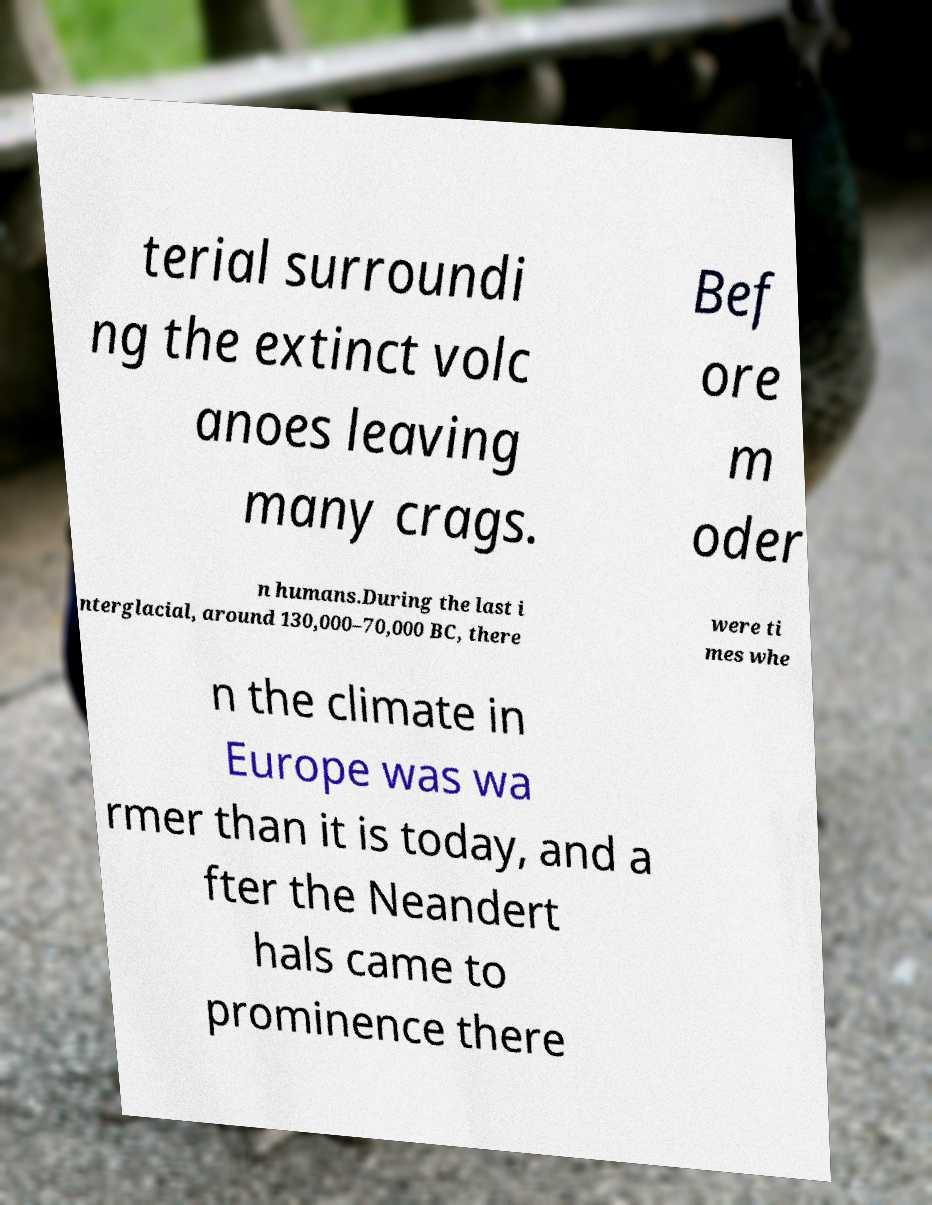For documentation purposes, I need the text within this image transcribed. Could you provide that? terial surroundi ng the extinct volc anoes leaving many crags. Bef ore m oder n humans.During the last i nterglacial, around 130,000–70,000 BC, there were ti mes whe n the climate in Europe was wa rmer than it is today, and a fter the Neandert hals came to prominence there 